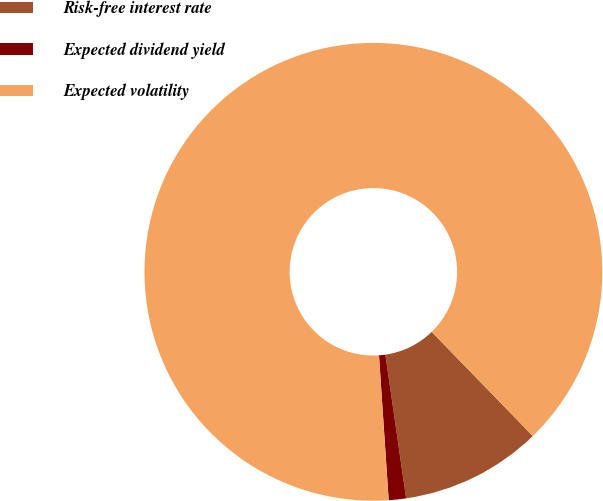Convert chart. <chart><loc_0><loc_0><loc_500><loc_500><pie_chart><fcel>Risk-free interest rate<fcel>Expected dividend yield<fcel>Expected volatility<nl><fcel>9.98%<fcel>1.22%<fcel>88.8%<nl></chart> 